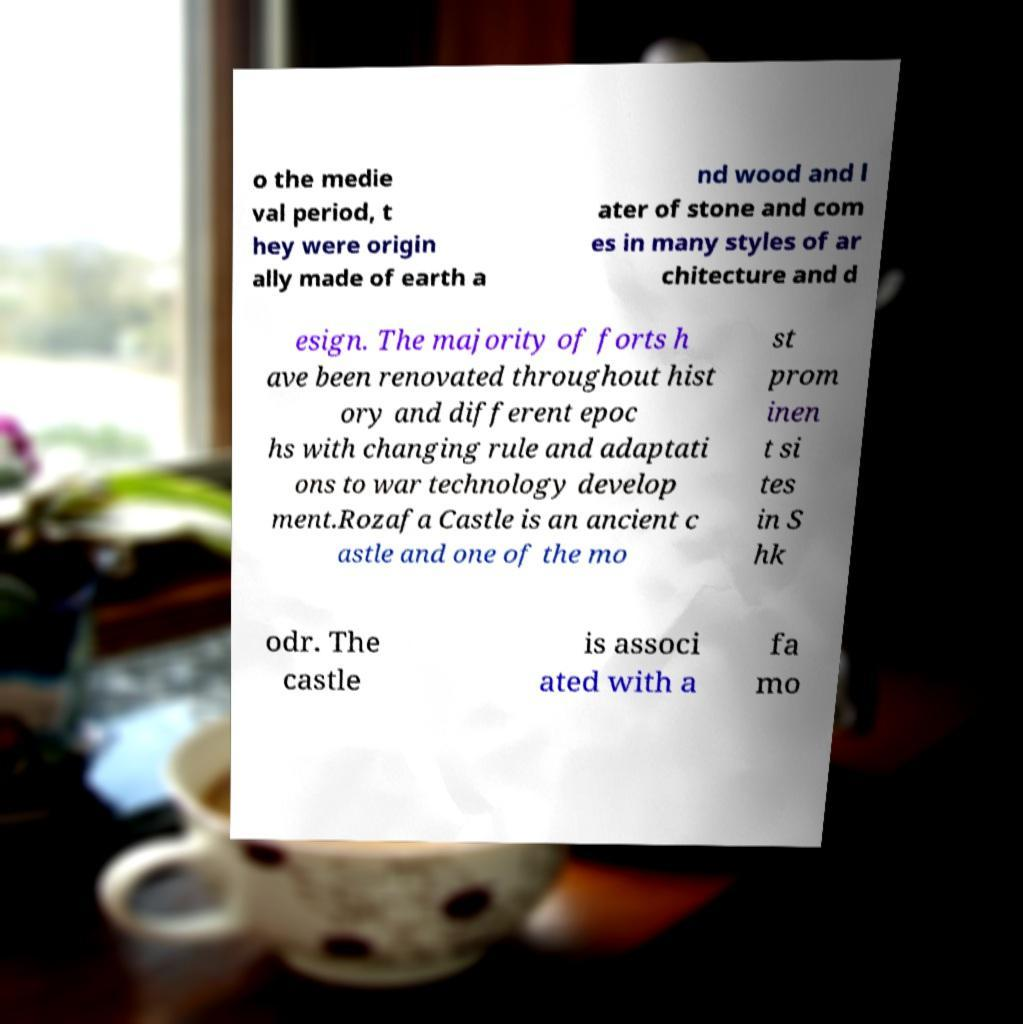Can you accurately transcribe the text from the provided image for me? o the medie val period, t hey were origin ally made of earth a nd wood and l ater of stone and com es in many styles of ar chitecture and d esign. The majority of forts h ave been renovated throughout hist ory and different epoc hs with changing rule and adaptati ons to war technology develop ment.Rozafa Castle is an ancient c astle and one of the mo st prom inen t si tes in S hk odr. The castle is associ ated with a fa mo 